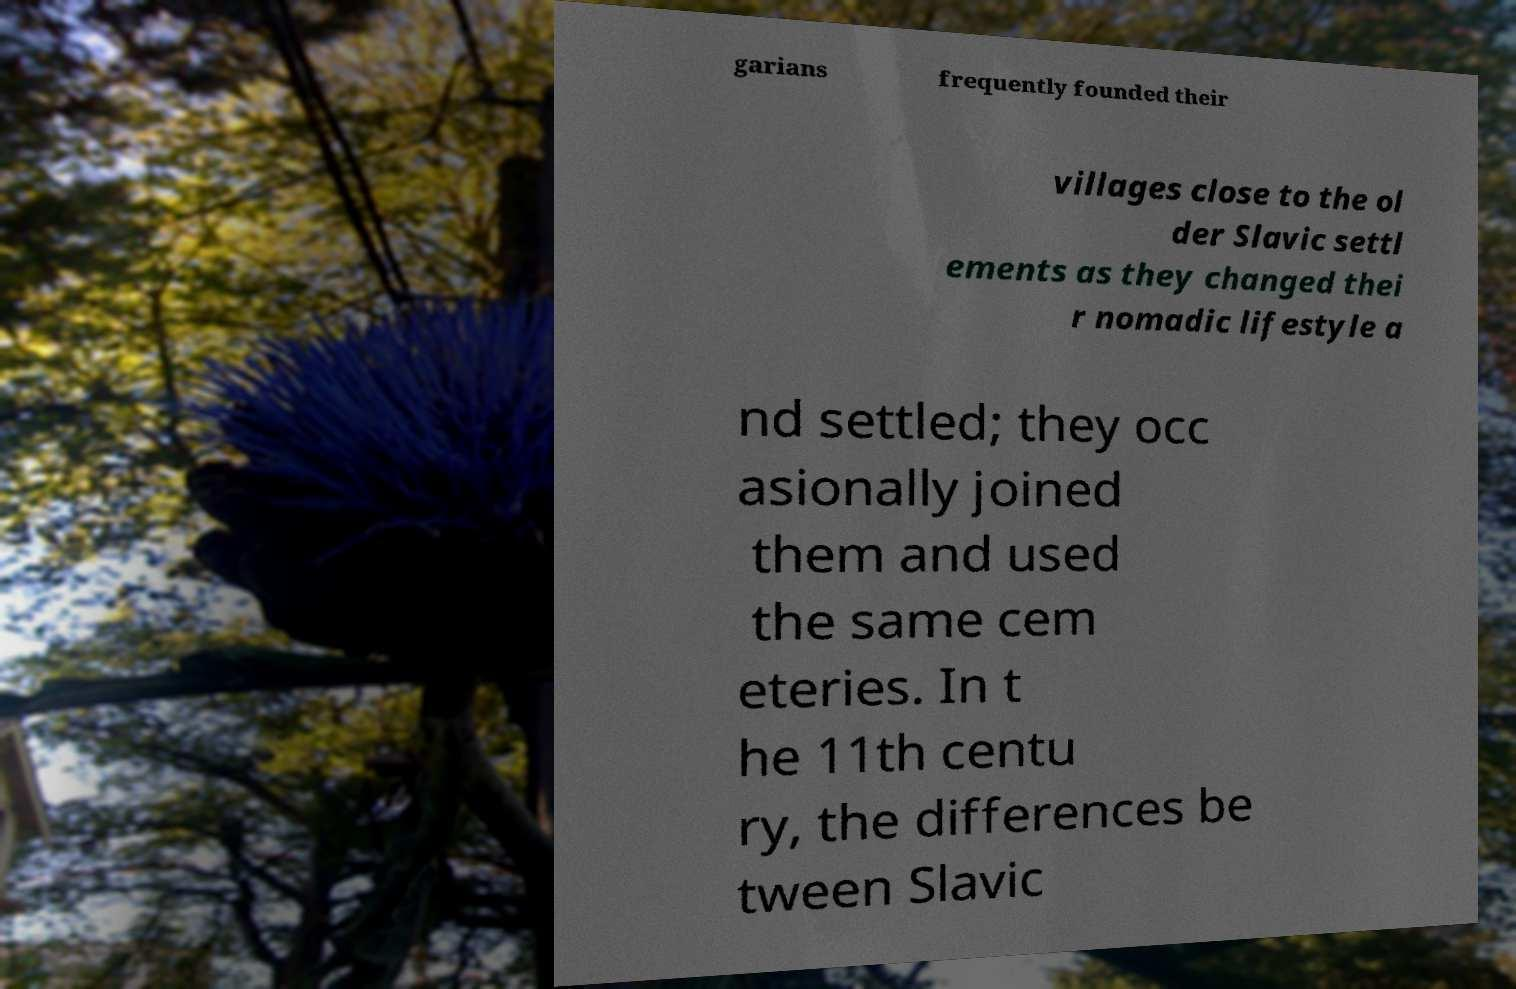Could you extract and type out the text from this image? garians frequently founded their villages close to the ol der Slavic settl ements as they changed thei r nomadic lifestyle a nd settled; they occ asionally joined them and used the same cem eteries. In t he 11th centu ry, the differences be tween Slavic 